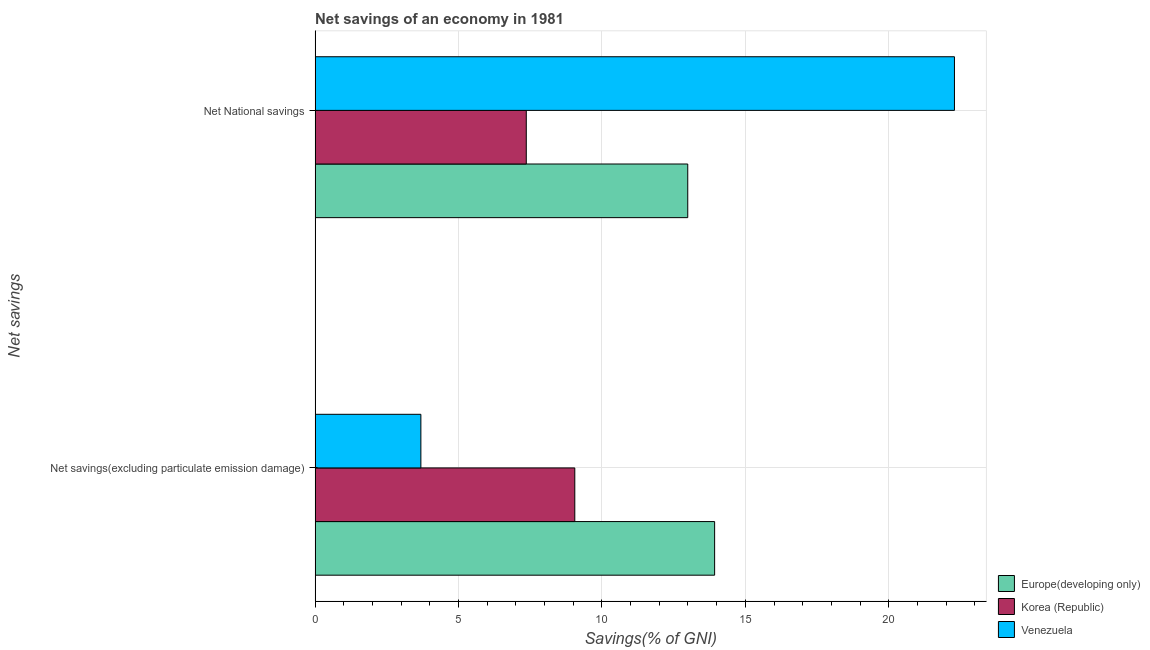Are the number of bars per tick equal to the number of legend labels?
Ensure brevity in your answer.  Yes. What is the label of the 1st group of bars from the top?
Your response must be concise. Net National savings. What is the net savings(excluding particulate emission damage) in Korea (Republic)?
Provide a succinct answer. 9.05. Across all countries, what is the maximum net savings(excluding particulate emission damage)?
Your answer should be very brief. 13.93. Across all countries, what is the minimum net savings(excluding particulate emission damage)?
Provide a short and direct response. 3.69. In which country was the net national savings maximum?
Keep it short and to the point. Venezuela. In which country was the net savings(excluding particulate emission damage) minimum?
Your answer should be very brief. Venezuela. What is the total net national savings in the graph?
Your answer should be compact. 42.65. What is the difference between the net savings(excluding particulate emission damage) in Europe(developing only) and that in Venezuela?
Provide a succinct answer. 10.24. What is the difference between the net savings(excluding particulate emission damage) in Korea (Republic) and the net national savings in Europe(developing only)?
Provide a short and direct response. -3.94. What is the average net savings(excluding particulate emission damage) per country?
Offer a very short reply. 8.89. What is the difference between the net national savings and net savings(excluding particulate emission damage) in Europe(developing only)?
Provide a succinct answer. -0.94. In how many countries, is the net savings(excluding particulate emission damage) greater than 19 %?
Give a very brief answer. 0. What is the ratio of the net national savings in Korea (Republic) to that in Venezuela?
Your response must be concise. 0.33. In how many countries, is the net savings(excluding particulate emission damage) greater than the average net savings(excluding particulate emission damage) taken over all countries?
Make the answer very short. 2. How many bars are there?
Give a very brief answer. 6. What is the difference between two consecutive major ticks on the X-axis?
Give a very brief answer. 5. Are the values on the major ticks of X-axis written in scientific E-notation?
Provide a short and direct response. No. Does the graph contain any zero values?
Provide a short and direct response. No. How many legend labels are there?
Ensure brevity in your answer.  3. How are the legend labels stacked?
Ensure brevity in your answer.  Vertical. What is the title of the graph?
Provide a short and direct response. Net savings of an economy in 1981. What is the label or title of the X-axis?
Your answer should be very brief. Savings(% of GNI). What is the label or title of the Y-axis?
Your answer should be compact. Net savings. What is the Savings(% of GNI) in Europe(developing only) in Net savings(excluding particulate emission damage)?
Provide a short and direct response. 13.93. What is the Savings(% of GNI) in Korea (Republic) in Net savings(excluding particulate emission damage)?
Offer a very short reply. 9.05. What is the Savings(% of GNI) of Venezuela in Net savings(excluding particulate emission damage)?
Keep it short and to the point. 3.69. What is the Savings(% of GNI) in Europe(developing only) in Net National savings?
Ensure brevity in your answer.  12.99. What is the Savings(% of GNI) in Korea (Republic) in Net National savings?
Ensure brevity in your answer.  7.36. What is the Savings(% of GNI) in Venezuela in Net National savings?
Ensure brevity in your answer.  22.29. Across all Net savings, what is the maximum Savings(% of GNI) in Europe(developing only)?
Offer a terse response. 13.93. Across all Net savings, what is the maximum Savings(% of GNI) in Korea (Republic)?
Ensure brevity in your answer.  9.05. Across all Net savings, what is the maximum Savings(% of GNI) in Venezuela?
Offer a very short reply. 22.29. Across all Net savings, what is the minimum Savings(% of GNI) of Europe(developing only)?
Your answer should be very brief. 12.99. Across all Net savings, what is the minimum Savings(% of GNI) of Korea (Republic)?
Give a very brief answer. 7.36. Across all Net savings, what is the minimum Savings(% of GNI) of Venezuela?
Your answer should be very brief. 3.69. What is the total Savings(% of GNI) in Europe(developing only) in the graph?
Make the answer very short. 26.92. What is the total Savings(% of GNI) in Korea (Republic) in the graph?
Offer a very short reply. 16.42. What is the total Savings(% of GNI) in Venezuela in the graph?
Ensure brevity in your answer.  25.98. What is the difference between the Savings(% of GNI) of Europe(developing only) in Net savings(excluding particulate emission damage) and that in Net National savings?
Ensure brevity in your answer.  0.94. What is the difference between the Savings(% of GNI) in Korea (Republic) in Net savings(excluding particulate emission damage) and that in Net National savings?
Offer a very short reply. 1.69. What is the difference between the Savings(% of GNI) in Venezuela in Net savings(excluding particulate emission damage) and that in Net National savings?
Your answer should be very brief. -18.6. What is the difference between the Savings(% of GNI) in Europe(developing only) in Net savings(excluding particulate emission damage) and the Savings(% of GNI) in Korea (Republic) in Net National savings?
Make the answer very short. 6.57. What is the difference between the Savings(% of GNI) in Europe(developing only) in Net savings(excluding particulate emission damage) and the Savings(% of GNI) in Venezuela in Net National savings?
Keep it short and to the point. -8.36. What is the difference between the Savings(% of GNI) in Korea (Republic) in Net savings(excluding particulate emission damage) and the Savings(% of GNI) in Venezuela in Net National savings?
Keep it short and to the point. -13.24. What is the average Savings(% of GNI) of Europe(developing only) per Net savings?
Provide a succinct answer. 13.46. What is the average Savings(% of GNI) of Korea (Republic) per Net savings?
Provide a short and direct response. 8.21. What is the average Savings(% of GNI) in Venezuela per Net savings?
Offer a very short reply. 12.99. What is the difference between the Savings(% of GNI) in Europe(developing only) and Savings(% of GNI) in Korea (Republic) in Net savings(excluding particulate emission damage)?
Offer a very short reply. 4.88. What is the difference between the Savings(% of GNI) of Europe(developing only) and Savings(% of GNI) of Venezuela in Net savings(excluding particulate emission damage)?
Offer a very short reply. 10.24. What is the difference between the Savings(% of GNI) of Korea (Republic) and Savings(% of GNI) of Venezuela in Net savings(excluding particulate emission damage)?
Make the answer very short. 5.37. What is the difference between the Savings(% of GNI) of Europe(developing only) and Savings(% of GNI) of Korea (Republic) in Net National savings?
Provide a succinct answer. 5.63. What is the difference between the Savings(% of GNI) of Europe(developing only) and Savings(% of GNI) of Venezuela in Net National savings?
Keep it short and to the point. -9.3. What is the difference between the Savings(% of GNI) in Korea (Republic) and Savings(% of GNI) in Venezuela in Net National savings?
Offer a very short reply. -14.93. What is the ratio of the Savings(% of GNI) of Europe(developing only) in Net savings(excluding particulate emission damage) to that in Net National savings?
Your response must be concise. 1.07. What is the ratio of the Savings(% of GNI) of Korea (Republic) in Net savings(excluding particulate emission damage) to that in Net National savings?
Offer a very short reply. 1.23. What is the ratio of the Savings(% of GNI) in Venezuela in Net savings(excluding particulate emission damage) to that in Net National savings?
Make the answer very short. 0.17. What is the difference between the highest and the second highest Savings(% of GNI) in Europe(developing only)?
Offer a very short reply. 0.94. What is the difference between the highest and the second highest Savings(% of GNI) of Korea (Republic)?
Keep it short and to the point. 1.69. What is the difference between the highest and the second highest Savings(% of GNI) in Venezuela?
Offer a terse response. 18.6. What is the difference between the highest and the lowest Savings(% of GNI) of Europe(developing only)?
Give a very brief answer. 0.94. What is the difference between the highest and the lowest Savings(% of GNI) in Korea (Republic)?
Your answer should be very brief. 1.69. What is the difference between the highest and the lowest Savings(% of GNI) of Venezuela?
Provide a succinct answer. 18.6. 